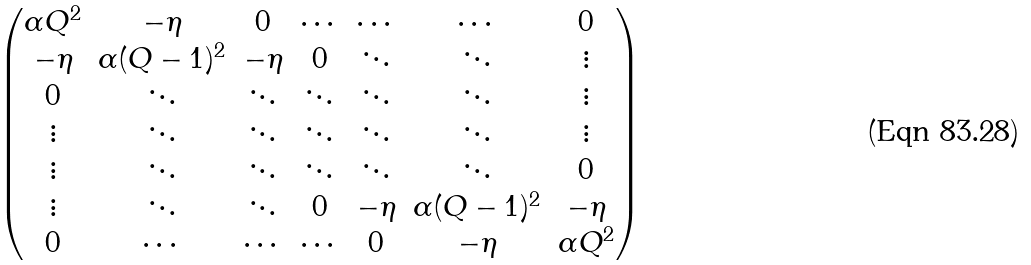<formula> <loc_0><loc_0><loc_500><loc_500>\begin{pmatrix} \alpha Q ^ { 2 } & - \eta & 0 & \cdots & \cdots & \cdots & 0 \\ - \eta & \alpha ( Q - 1 ) ^ { 2 } & - \eta & 0 & \ddots & \ddots & \vdots \\ 0 & \ddots & \ddots & \ddots & \ddots & \ddots & \vdots \\ \vdots & \ddots & \ddots & \ddots & \ddots & \ddots & \vdots \\ \vdots & \ddots & \ddots & \ddots & \ddots & \ddots & 0 \\ \vdots & \ddots & \ddots & 0 & - \eta & \alpha ( Q - 1 ) ^ { 2 } & - \eta \\ 0 & \cdots & \cdots & \cdots & 0 & - \eta & \alpha Q ^ { 2 } \end{pmatrix}</formula> 